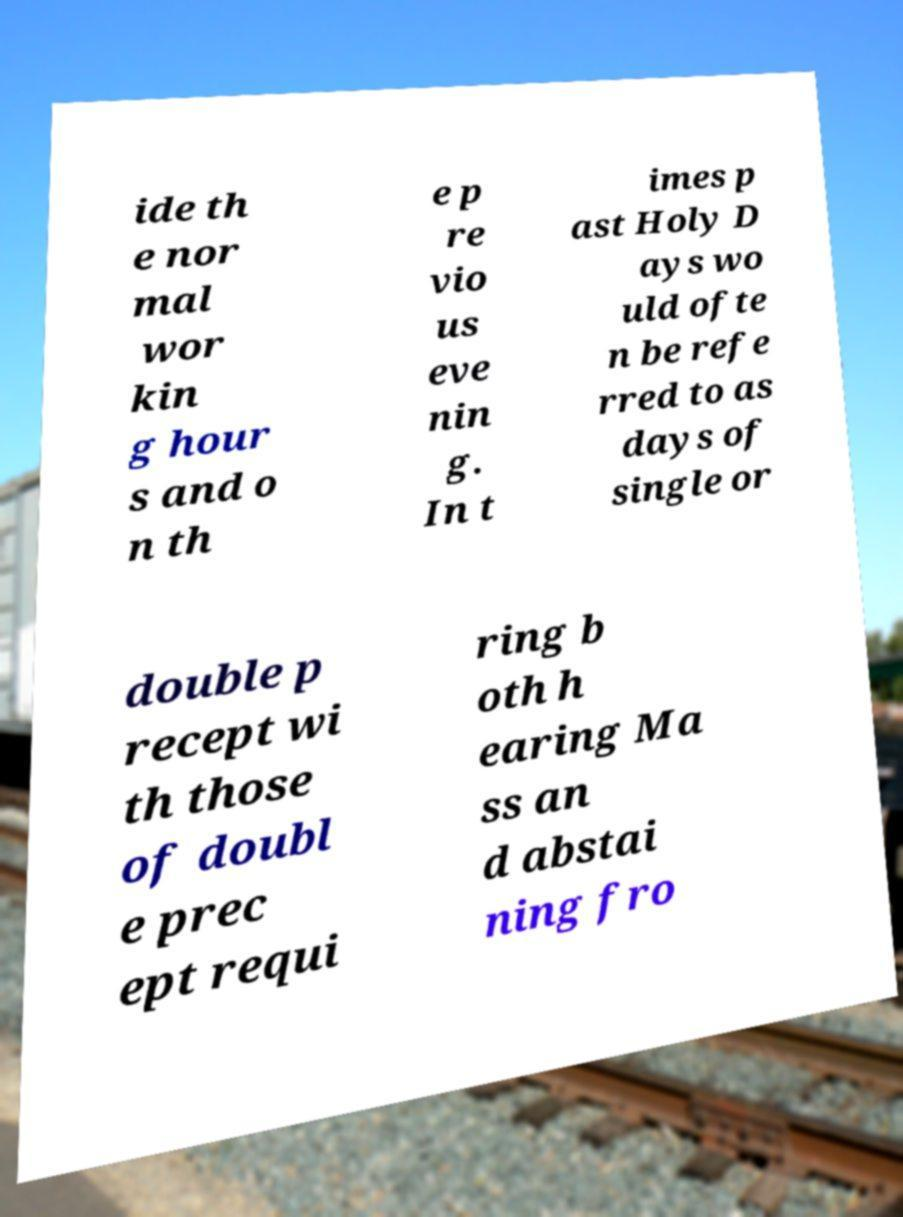Could you extract and type out the text from this image? ide th e nor mal wor kin g hour s and o n th e p re vio us eve nin g. In t imes p ast Holy D ays wo uld ofte n be refe rred to as days of single or double p recept wi th those of doubl e prec ept requi ring b oth h earing Ma ss an d abstai ning fro 